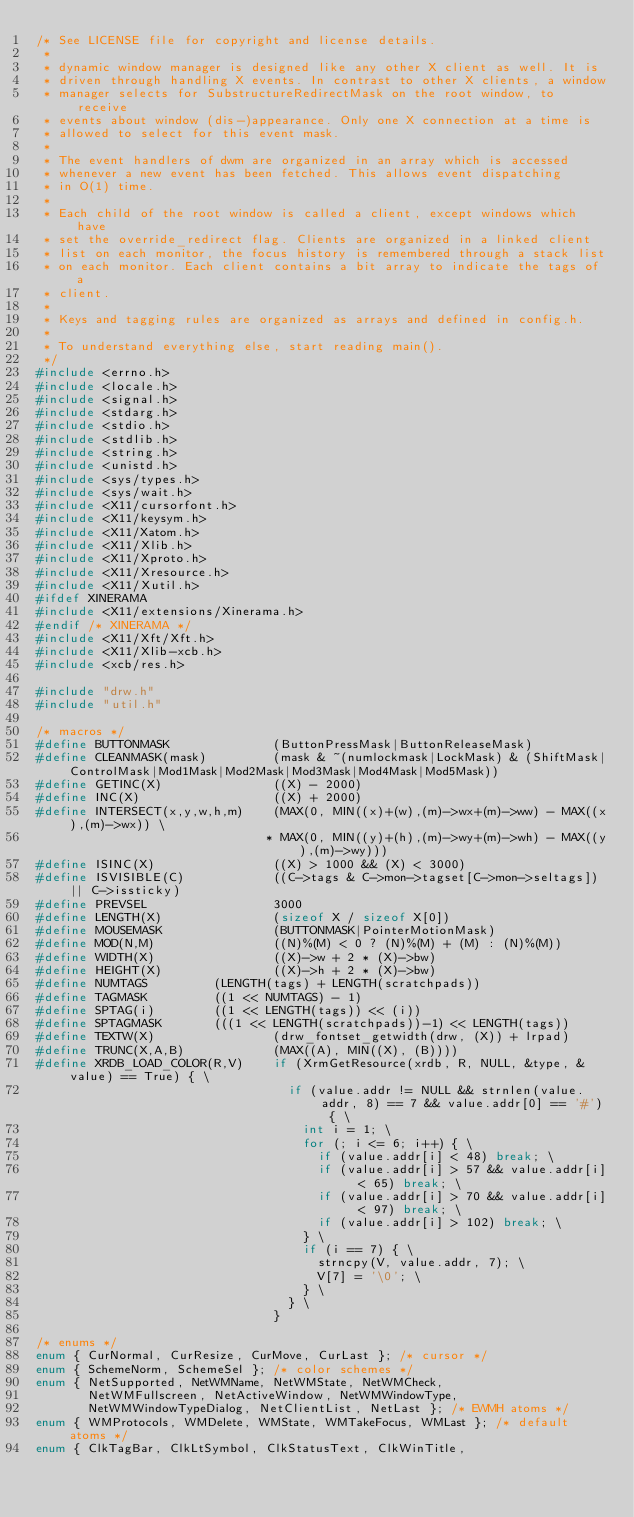Convert code to text. <code><loc_0><loc_0><loc_500><loc_500><_C_>/* See LICENSE file for copyright and license details.
 *
 * dynamic window manager is designed like any other X client as well. It is
 * driven through handling X events. In contrast to other X clients, a window
 * manager selects for SubstructureRedirectMask on the root window, to receive
 * events about window (dis-)appearance. Only one X connection at a time is
 * allowed to select for this event mask.
 *
 * The event handlers of dwm are organized in an array which is accessed
 * whenever a new event has been fetched. This allows event dispatching
 * in O(1) time.
 *
 * Each child of the root window is called a client, except windows which have
 * set the override_redirect flag. Clients are organized in a linked client
 * list on each monitor, the focus history is remembered through a stack list
 * on each monitor. Each client contains a bit array to indicate the tags of a
 * client.
 *
 * Keys and tagging rules are organized as arrays and defined in config.h.
 *
 * To understand everything else, start reading main().
 */
#include <errno.h>
#include <locale.h>
#include <signal.h>
#include <stdarg.h>
#include <stdio.h>
#include <stdlib.h>
#include <string.h>
#include <unistd.h>
#include <sys/types.h>
#include <sys/wait.h>
#include <X11/cursorfont.h>
#include <X11/keysym.h>
#include <X11/Xatom.h>
#include <X11/Xlib.h>
#include <X11/Xproto.h>
#include <X11/Xresource.h>
#include <X11/Xutil.h>
#ifdef XINERAMA
#include <X11/extensions/Xinerama.h>
#endif /* XINERAMA */
#include <X11/Xft/Xft.h>
#include <X11/Xlib-xcb.h>
#include <xcb/res.h>

#include "drw.h"
#include "util.h"

/* macros */
#define BUTTONMASK              (ButtonPressMask|ButtonReleaseMask)
#define CLEANMASK(mask)         (mask & ~(numlockmask|LockMask) & (ShiftMask|ControlMask|Mod1Mask|Mod2Mask|Mod3Mask|Mod4Mask|Mod5Mask))
#define GETINC(X)               ((X) - 2000)
#define INC(X)                  ((X) + 2000)
#define INTERSECT(x,y,w,h,m)    (MAX(0, MIN((x)+(w),(m)->wx+(m)->ww) - MAX((x),(m)->wx)) \
                               * MAX(0, MIN((y)+(h),(m)->wy+(m)->wh) - MAX((y),(m)->wy)))
#define ISINC(X)                ((X) > 1000 && (X) < 3000)
#define ISVISIBLE(C)            ((C->tags & C->mon->tagset[C->mon->seltags]) || C->issticky)
#define PREVSEL                 3000
#define LENGTH(X)               (sizeof X / sizeof X[0])
#define MOUSEMASK               (BUTTONMASK|PointerMotionMask)
#define MOD(N,M)                ((N)%(M) < 0 ? (N)%(M) + (M) : (N)%(M))
#define WIDTH(X)                ((X)->w + 2 * (X)->bw)
#define HEIGHT(X)               ((X)->h + 2 * (X)->bw)
#define NUMTAGS			(LENGTH(tags) + LENGTH(scratchpads))
#define TAGMASK			((1 << NUMTAGS) - 1)
#define SPTAG(i)		((1 << LENGTH(tags)) << (i))
#define SPTAGMASK		(((1 << LENGTH(scratchpads))-1) << LENGTH(tags))
#define TEXTW(X)                (drw_fontset_getwidth(drw, (X)) + lrpad)
#define TRUNC(X,A,B)            (MAX((A), MIN((X), (B))))
#define XRDB_LOAD_COLOR(R,V)    if (XrmGetResource(xrdb, R, NULL, &type, &value) == True) { \
                                  if (value.addr != NULL && strnlen(value.addr, 8) == 7 && value.addr[0] == '#') { \
                                    int i = 1; \
                                    for (; i <= 6; i++) { \
                                      if (value.addr[i] < 48) break; \
                                      if (value.addr[i] > 57 && value.addr[i] < 65) break; \
                                      if (value.addr[i] > 70 && value.addr[i] < 97) break; \
                                      if (value.addr[i] > 102) break; \
                                    } \
                                    if (i == 7) { \
                                      strncpy(V, value.addr, 7); \
                                      V[7] = '\0'; \
                                    } \
                                  } \
                                }

/* enums */
enum { CurNormal, CurResize, CurMove, CurLast }; /* cursor */
enum { SchemeNorm, SchemeSel }; /* color schemes */
enum { NetSupported, NetWMName, NetWMState, NetWMCheck,
       NetWMFullscreen, NetActiveWindow, NetWMWindowType,
       NetWMWindowTypeDialog, NetClientList, NetLast }; /* EWMH atoms */
enum { WMProtocols, WMDelete, WMState, WMTakeFocus, WMLast }; /* default atoms */
enum { ClkTagBar, ClkLtSymbol, ClkStatusText, ClkWinTitle,</code> 